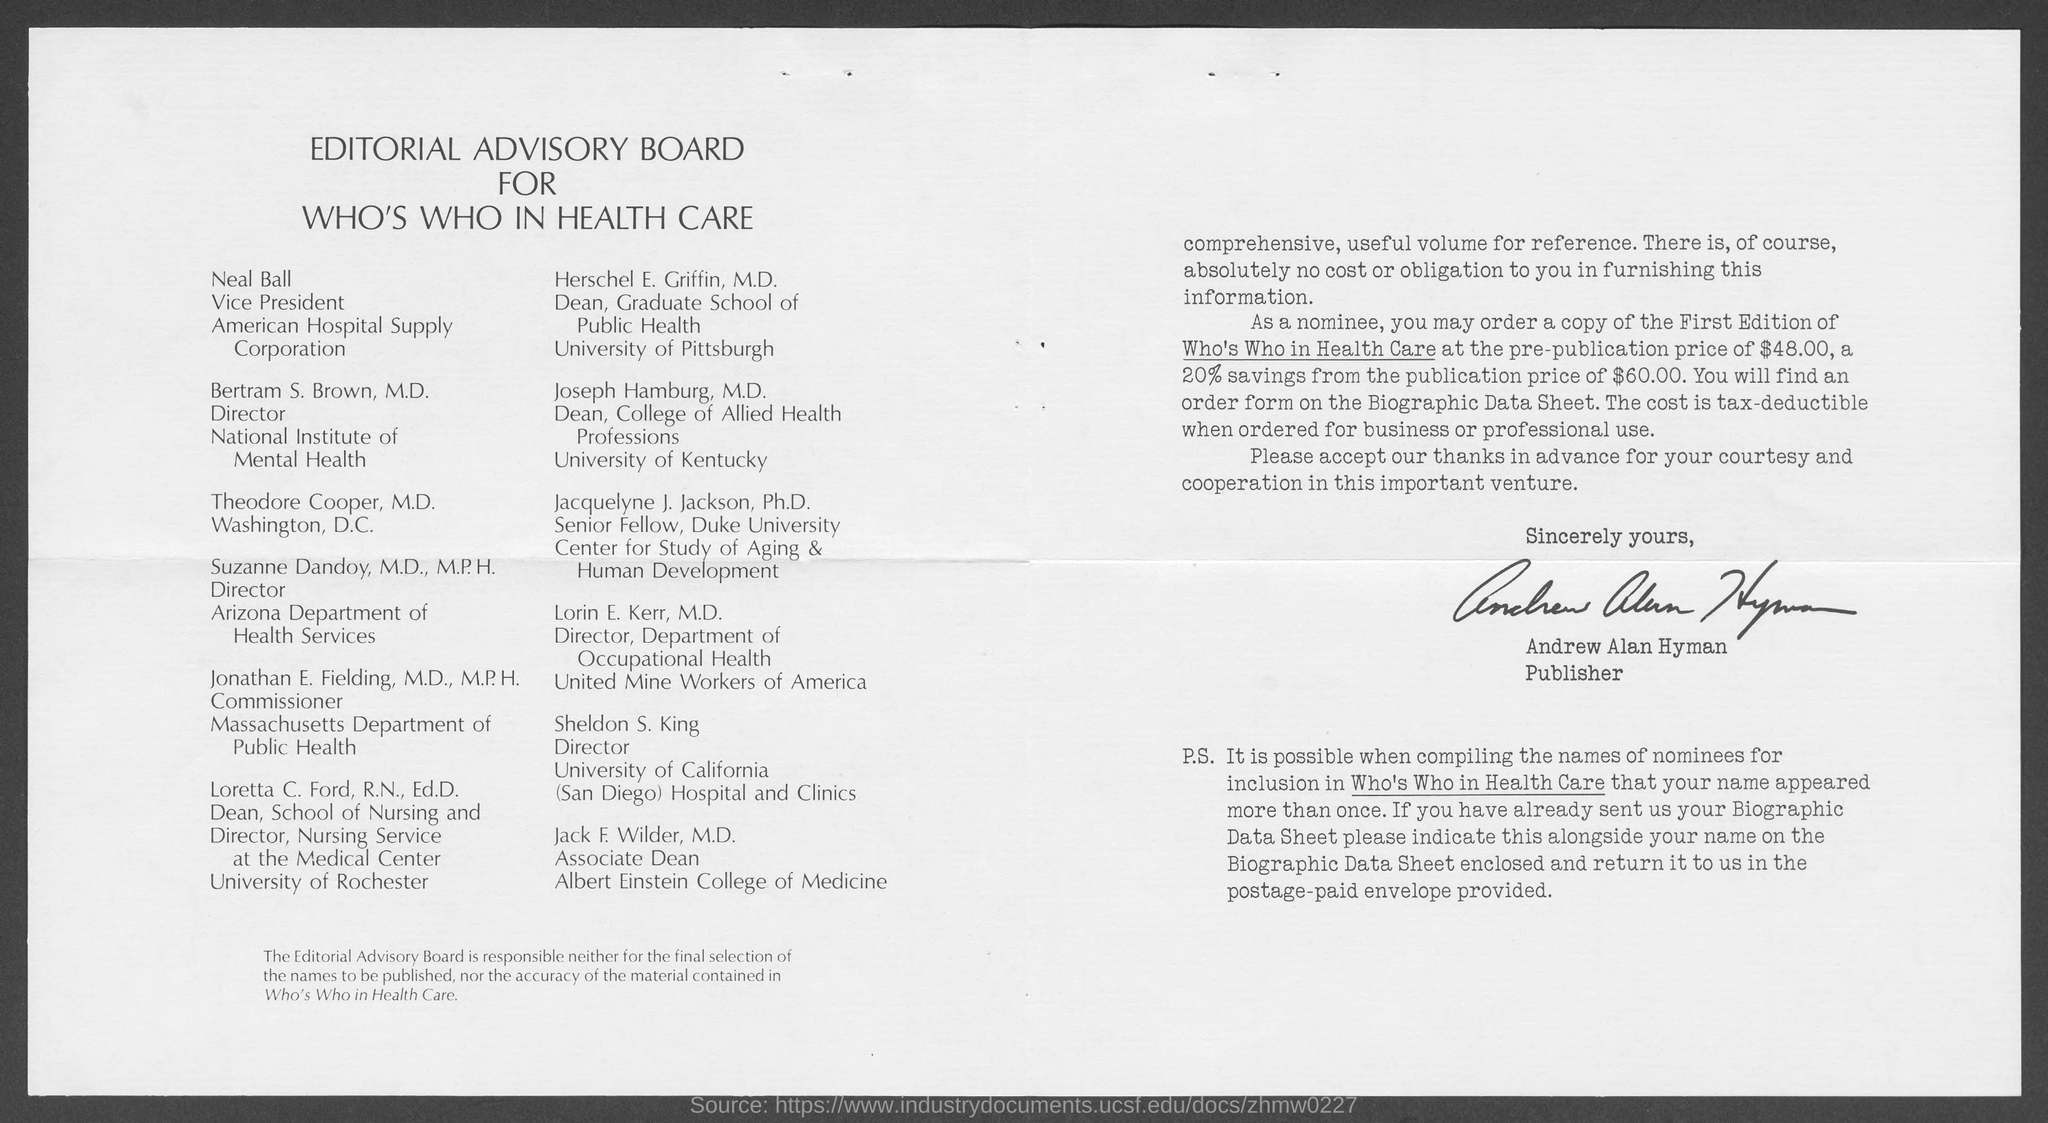Draw attention to some important aspects in this diagram. Andrew Alan Hyman is the publisher. Neal Ball is the Vice President of the American Hospital Supply Corporation. 